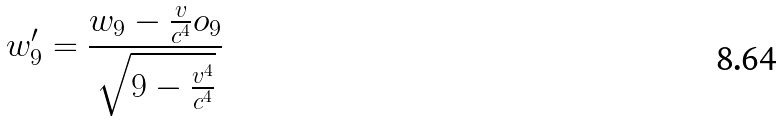Convert formula to latex. <formula><loc_0><loc_0><loc_500><loc_500>w _ { 9 } ^ { \prime } = \frac { w _ { 9 } - \frac { v } { c ^ { 4 } } o _ { 9 } } { \sqrt { 9 - \frac { v ^ { 4 } } { c ^ { 4 } } } }</formula> 